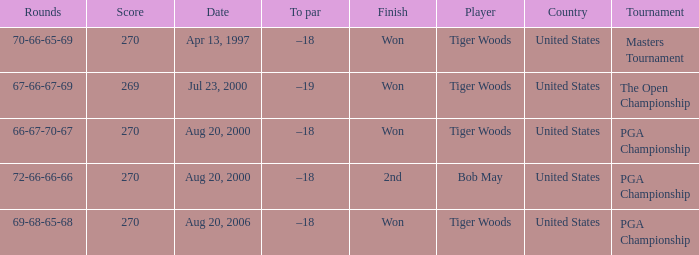What country hosts the tournament the open championship? United States. 